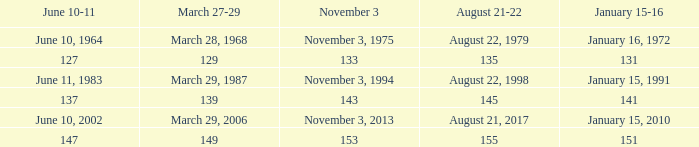What is shown for  august 21-22 when november 3 is november 3, 1994? August 22, 1998. 